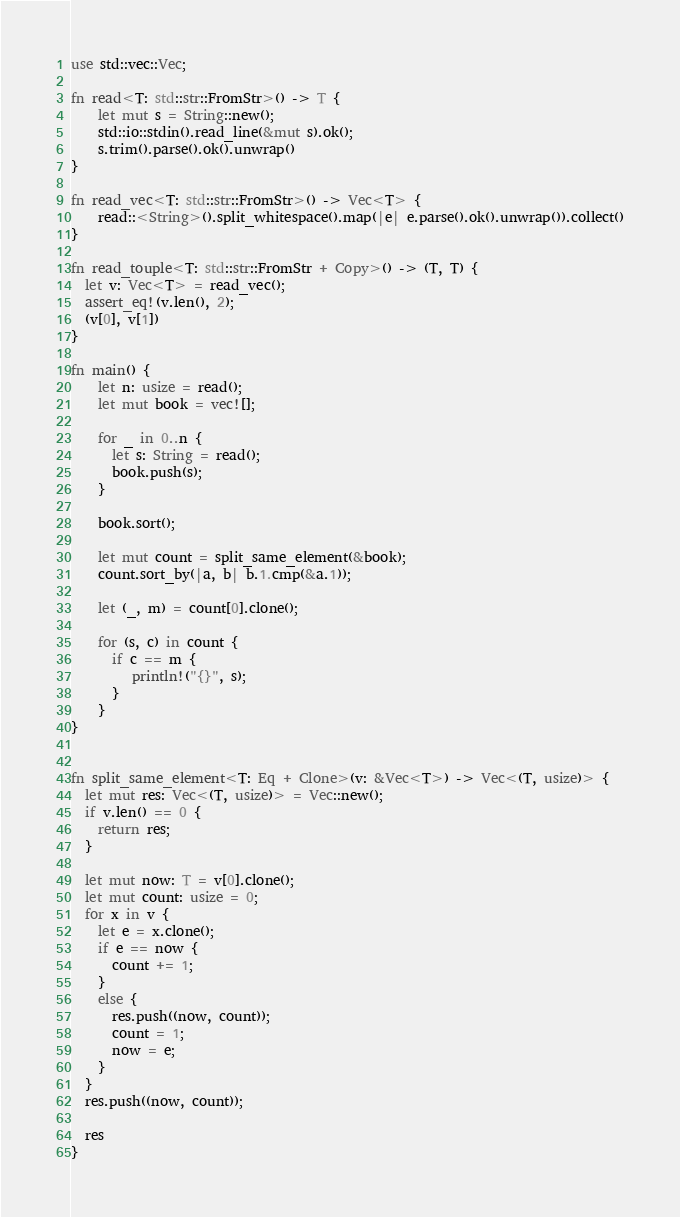<code> <loc_0><loc_0><loc_500><loc_500><_Rust_>use std::vec::Vec;

fn read<T: std::str::FromStr>() -> T {
    let mut s = String::new();
    std::io::stdin().read_line(&mut s).ok();
    s.trim().parse().ok().unwrap()
}

fn read_vec<T: std::str::FromStr>() -> Vec<T> {
    read::<String>().split_whitespace().map(|e| e.parse().ok().unwrap()).collect()
}

fn read_touple<T: std::str::FromStr + Copy>() -> (T, T) {
  let v: Vec<T> = read_vec();
  assert_eq!(v.len(), 2);
  (v[0], v[1])
}

fn main() {
    let n: usize = read();
    let mut book = vec![];

    for _ in 0..n {
      let s: String = read();
      book.push(s);
    }

    book.sort();

    let mut count = split_same_element(&book);
    count.sort_by(|a, b| b.1.cmp(&a.1));
    
    let (_, m) = count[0].clone();

    for (s, c) in count {
      if c == m {
         println!("{}", s);
      }
    }
}


fn split_same_element<T: Eq + Clone>(v: &Vec<T>) -> Vec<(T, usize)> {
  let mut res: Vec<(T, usize)> = Vec::new();
  if v.len() == 0 {
    return res;
  }

  let mut now: T = v[0].clone();
  let mut count: usize = 0;
  for x in v {
    let e = x.clone();
    if e == now {
      count += 1;
    }
    else {
      res.push((now, count));
      count = 1;
      now = e;
    }
  }
  res.push((now, count));

  res
}</code> 